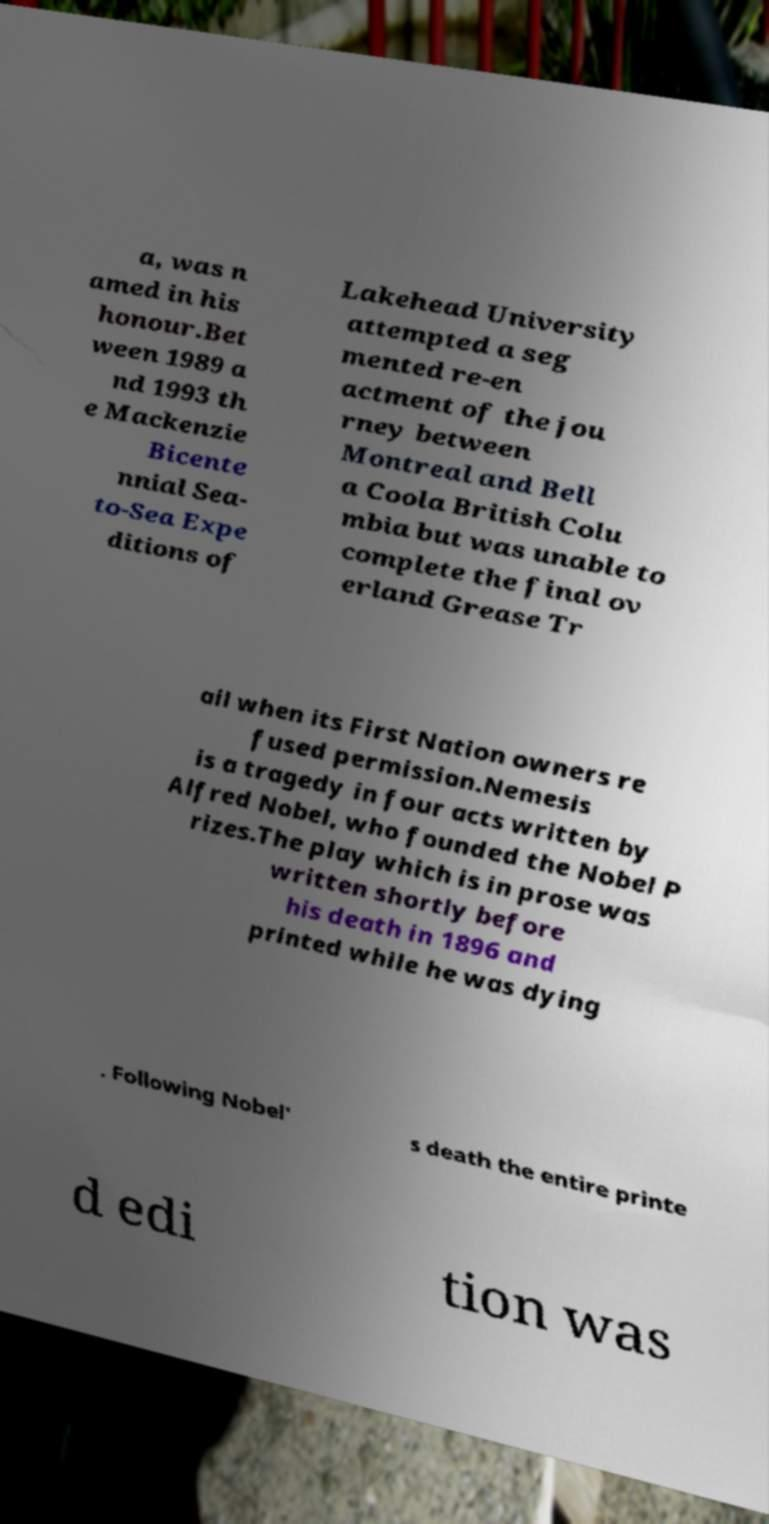I need the written content from this picture converted into text. Can you do that? a, was n amed in his honour.Bet ween 1989 a nd 1993 th e Mackenzie Bicente nnial Sea- to-Sea Expe ditions of Lakehead University attempted a seg mented re-en actment of the jou rney between Montreal and Bell a Coola British Colu mbia but was unable to complete the final ov erland Grease Tr ail when its First Nation owners re fused permission.Nemesis is a tragedy in four acts written by Alfred Nobel, who founded the Nobel P rizes.The play which is in prose was written shortly before his death in 1896 and printed while he was dying . Following Nobel' s death the entire printe d edi tion was 